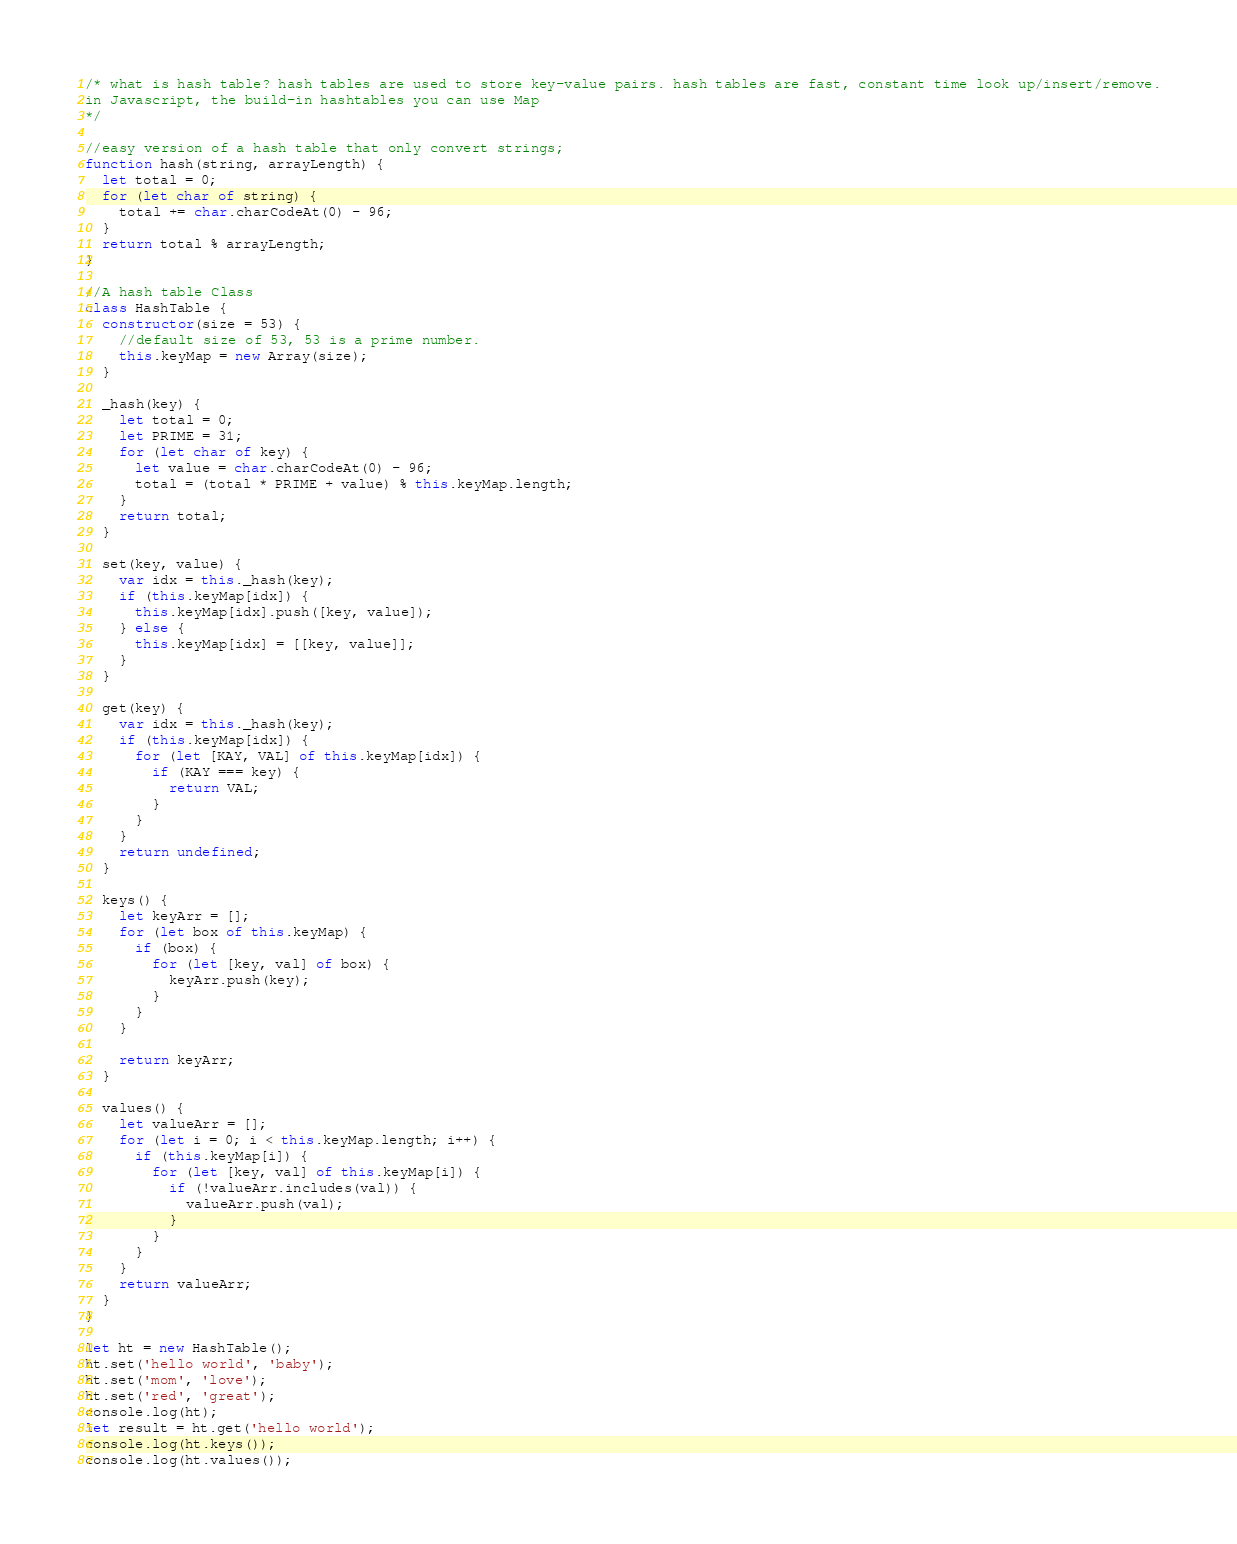Convert code to text. <code><loc_0><loc_0><loc_500><loc_500><_JavaScript_>/* what is hash table? hash tables are used to store key-value pairs. hash tables are fast, constant time look up/insert/remove.
in Javascript, the build-in hashtables you can use Map
*/

//easy version of a hash table that only convert strings;
function hash(string, arrayLength) {
  let total = 0;
  for (let char of string) {
    total += char.charCodeAt(0) - 96;
  }
  return total % arrayLength;
}

//A hash table Class
class HashTable {
  constructor(size = 53) {
    //default size of 53, 53 is a prime number.
    this.keyMap = new Array(size);
  }

  _hash(key) {
    let total = 0;
    let PRIME = 31;
    for (let char of key) {
      let value = char.charCodeAt(0) - 96;
      total = (total * PRIME + value) % this.keyMap.length;
    }
    return total;
  }

  set(key, value) {
    var idx = this._hash(key);
    if (this.keyMap[idx]) {
      this.keyMap[idx].push([key, value]);
    } else {
      this.keyMap[idx] = [[key, value]];
    }
  }

  get(key) {
    var idx = this._hash(key);
    if (this.keyMap[idx]) {
      for (let [KAY, VAL] of this.keyMap[idx]) {
        if (KAY === key) {
          return VAL;
        }
      }
    }
    return undefined;
  }

  keys() {
    let keyArr = [];
    for (let box of this.keyMap) {
      if (box) {
        for (let [key, val] of box) {
          keyArr.push(key);
        }
      }
    }

    return keyArr;
  }

  values() {
    let valueArr = [];
    for (let i = 0; i < this.keyMap.length; i++) {
      if (this.keyMap[i]) {
        for (let [key, val] of this.keyMap[i]) {
          if (!valueArr.includes(val)) {
            valueArr.push(val);
          }
        }
      }
    }
    return valueArr;
  }
}

let ht = new HashTable();
ht.set('hello world', 'baby');
ht.set('mom', 'love');
ht.set('red', 'great');
console.log(ht);
let result = ht.get('hello world');
console.log(ht.keys());
console.log(ht.values());
</code> 